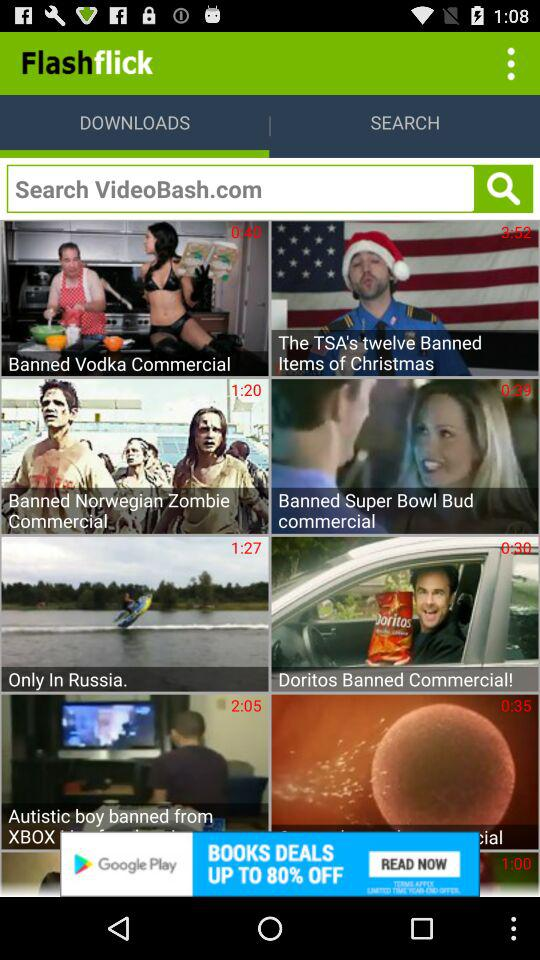Which tab am I on? You are on the "Downloads" tab. 